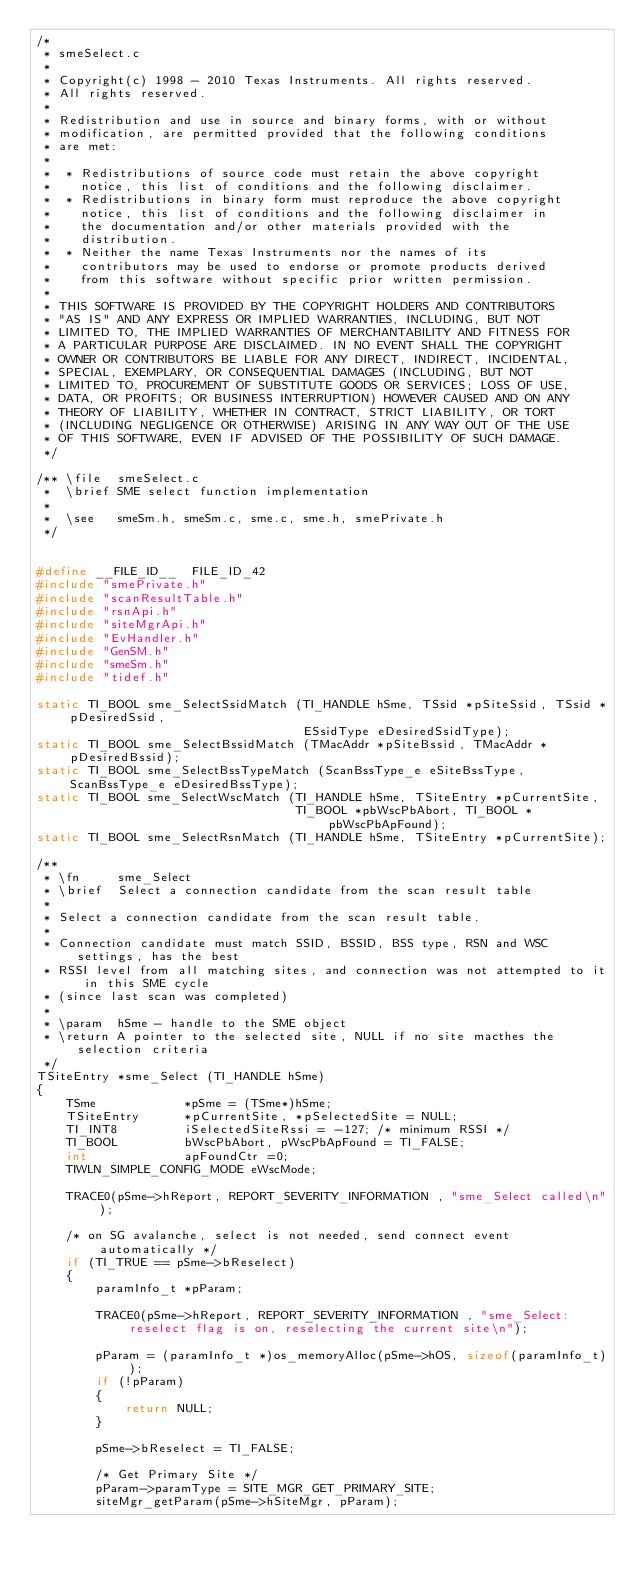<code> <loc_0><loc_0><loc_500><loc_500><_C_>/*
 * smeSelect.c
 *
 * Copyright(c) 1998 - 2010 Texas Instruments. All rights reserved.      
 * All rights reserved.                                                  
 *                                                                       
 * Redistribution and use in source and binary forms, with or without    
 * modification, are permitted provided that the following conditions    
 * are met:                                                              
 *                                                                       
 *  * Redistributions of source code must retain the above copyright     
 *    notice, this list of conditions and the following disclaimer.      
 *  * Redistributions in binary form must reproduce the above copyright  
 *    notice, this list of conditions and the following disclaimer in    
 *    the documentation and/or other materials provided with the         
 *    distribution.                                                      
 *  * Neither the name Texas Instruments nor the names of its            
 *    contributors may be used to endorse or promote products derived    
 *    from this software without specific prior written permission.      
 *                                                                       
 * THIS SOFTWARE IS PROVIDED BY THE COPYRIGHT HOLDERS AND CONTRIBUTORS   
 * "AS IS" AND ANY EXPRESS OR IMPLIED WARRANTIES, INCLUDING, BUT NOT     
 * LIMITED TO, THE IMPLIED WARRANTIES OF MERCHANTABILITY AND FITNESS FOR 
 * A PARTICULAR PURPOSE ARE DISCLAIMED. IN NO EVENT SHALL THE COPYRIGHT  
 * OWNER OR CONTRIBUTORS BE LIABLE FOR ANY DIRECT, INDIRECT, INCIDENTAL, 
 * SPECIAL, EXEMPLARY, OR CONSEQUENTIAL DAMAGES (INCLUDING, BUT NOT      
 * LIMITED TO, PROCUREMENT OF SUBSTITUTE GOODS OR SERVICES; LOSS OF USE, 
 * DATA, OR PROFITS; OR BUSINESS INTERRUPTION) HOWEVER CAUSED AND ON ANY 
 * THEORY OF LIABILITY, WHETHER IN CONTRACT, STRICT LIABILITY, OR TORT   
 * (INCLUDING NEGLIGENCE OR OTHERWISE) ARISING IN ANY WAY OUT OF THE USE 
 * OF THIS SOFTWARE, EVEN IF ADVISED OF THE POSSIBILITY OF SUCH DAMAGE.
 */

/** \file  smeSelect.c
 *  \brief SME select function implementation
 *
 *  \see   smeSm.h, smeSm.c, sme.c, sme.h, smePrivate.h
 */


#define __FILE_ID__  FILE_ID_42
#include "smePrivate.h"
#include "scanResultTable.h"
#include "rsnApi.h"
#include "siteMgrApi.h"
#include "EvHandler.h"
#include "GenSM.h"
#include "smeSm.h"
#include "tidef.h"

static TI_BOOL sme_SelectSsidMatch (TI_HANDLE hSme, TSsid *pSiteSsid, TSsid *pDesiredSsid, 
                                    ESsidType eDesiredSsidType);
static TI_BOOL sme_SelectBssidMatch (TMacAddr *pSiteBssid, TMacAddr *pDesiredBssid);
static TI_BOOL sme_SelectBssTypeMatch (ScanBssType_e eSiteBssType, ScanBssType_e eDesiredBssType);
static TI_BOOL sme_SelectWscMatch (TI_HANDLE hSme, TSiteEntry *pCurrentSite, 
                                   TI_BOOL *pbWscPbAbort, TI_BOOL *pbWscPbApFound);
static TI_BOOL sme_SelectRsnMatch (TI_HANDLE hSme, TSiteEntry *pCurrentSite);

/** 
 * \fn     sme_Select
 * \brief  Select a connection candidate from the scan result table
 * 
 * Select a connection candidate from the scan result table.
 * 
 * Connection candidate must match SSID, BSSID, BSS type, RSN and WSC settings, has the best
 * RSSI level from all matching sites, and connection was not attempted to it in this SME cycle
 * (since last scan was completed)
 * 
 * \param  hSme - handle to the SME object
 * \return A pointer to the selected site, NULL if no site macthes the selection criteria
 */ 
TSiteEntry *sme_Select (TI_HANDLE hSme)
{
    TSme            *pSme = (TSme*)hSme;
    TSiteEntry      *pCurrentSite, *pSelectedSite = NULL;
    TI_INT8         iSelectedSiteRssi = -127; /* minimum RSSI */
    TI_BOOL         bWscPbAbort, pWscPbApFound = TI_FALSE;
    int             apFoundCtr =0;
    TIWLN_SIMPLE_CONFIG_MODE eWscMode;

    TRACE0(pSme->hReport, REPORT_SEVERITY_INFORMATION , "sme_Select called\n");

    /* on SG avalanche, select is not needed, send connect event automatically */
    if (TI_TRUE == pSme->bReselect)
    {
        paramInfo_t *pParam;

        TRACE0(pSme->hReport, REPORT_SEVERITY_INFORMATION , "sme_Select: reselect flag is on, reselecting the current site\n");

        pParam = (paramInfo_t *)os_memoryAlloc(pSme->hOS, sizeof(paramInfo_t));
        if (!pParam)
        {
            return NULL;
        }

        pSme->bReselect = TI_FALSE;

        /* Get Primary Site */
        pParam->paramType = SITE_MGR_GET_PRIMARY_SITE;
        siteMgr_getParam(pSme->hSiteMgr, pParam);</code> 